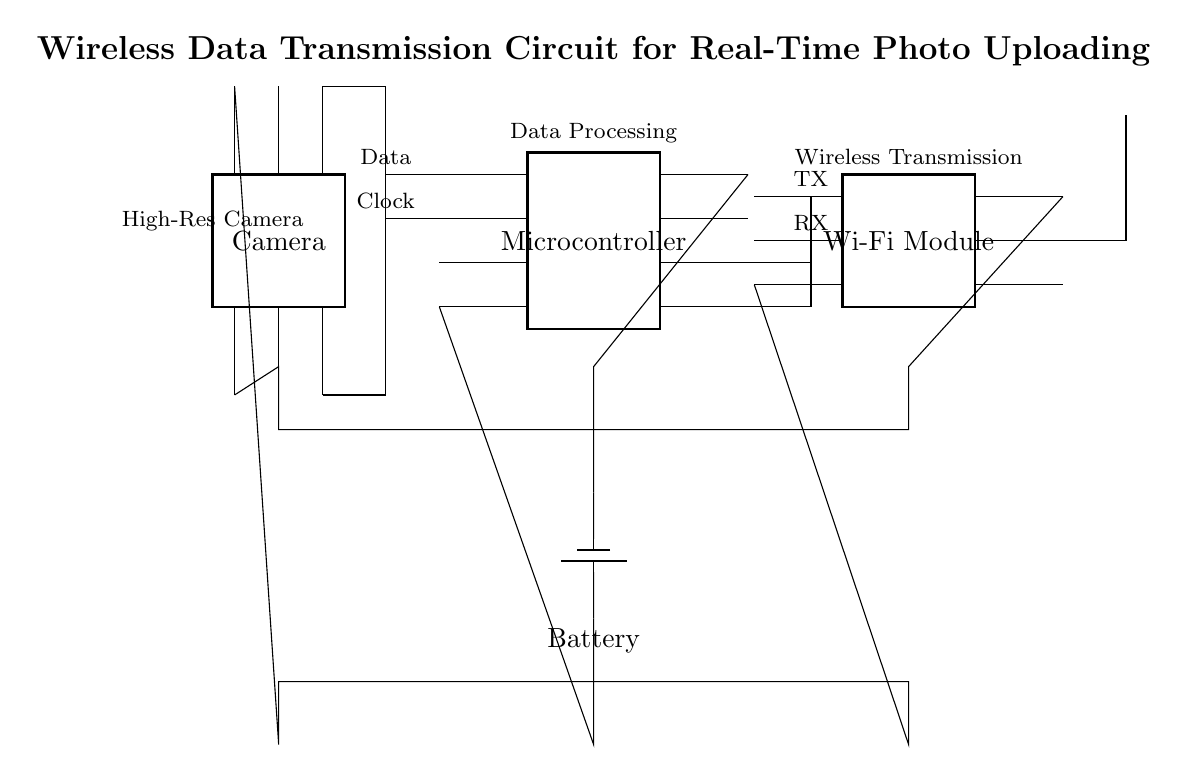What is the main function of the microcontroller in this circuit? The microcontroller processes the data received from the camera and manages the communication with the Wi-Fi module for transmitting images.
Answer: Data Processing How many pins does the Wi-Fi module have? The Wi-Fi module in the diagram is shown to have six pins labeled on its structure.
Answer: Six What is the role of the antenna in this circuit? The antenna allows the Wi-Fi module to transmit data wirelessly to the internet or other devices, which is crucial for real-time photo uploading.
Answer: Wireless Transmission Where does the power supply connect in the circuit? The power supply or battery connects to the microcontroller and camera, providing the necessary voltage, and also connects to the Wi-Fi module to power it.
Answer: Camera, Microcontroller, Wi-Fi Module What type of data connection is established between the camera and microcontroller? The connection between the camera and microcontroller is a data connection, specifically transferring video or image data from the camera to the processing unit for uploading.
Answer: Data How is the clock signal managed in this circuit? The clock signal is sent from the camera to the microcontroller, which uses it to synchronize the data transfer process and ensure that data is processed at the right times.
Answer: Synchronization 